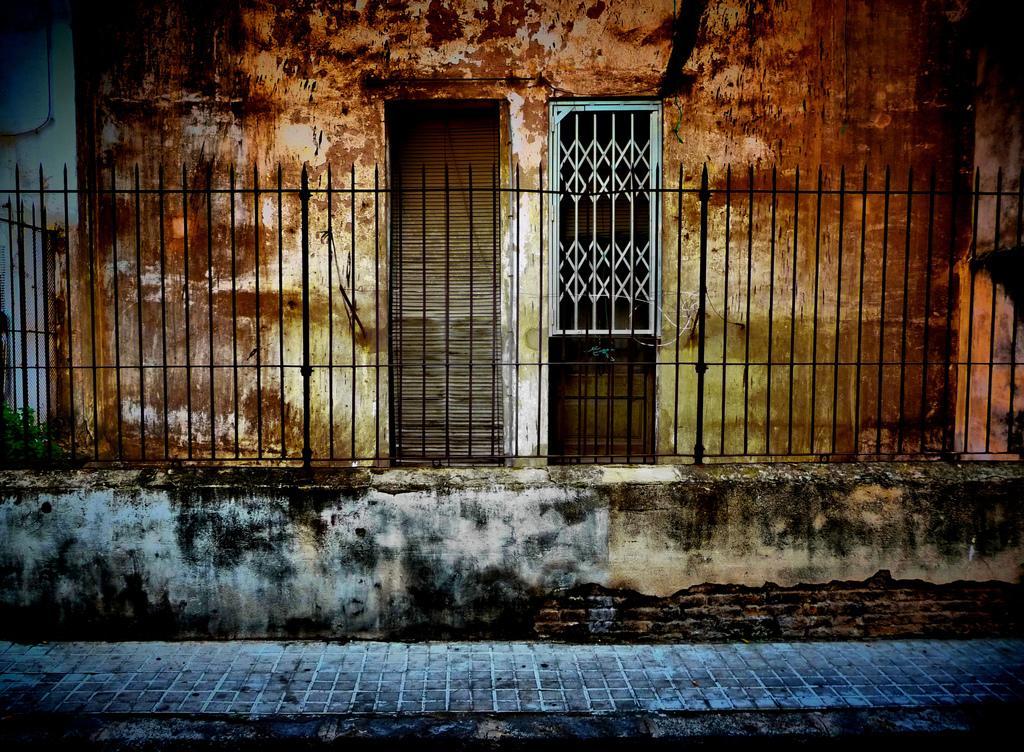Can you describe this image briefly? In this image we can see a fence, floor, wall, door, and a window. 